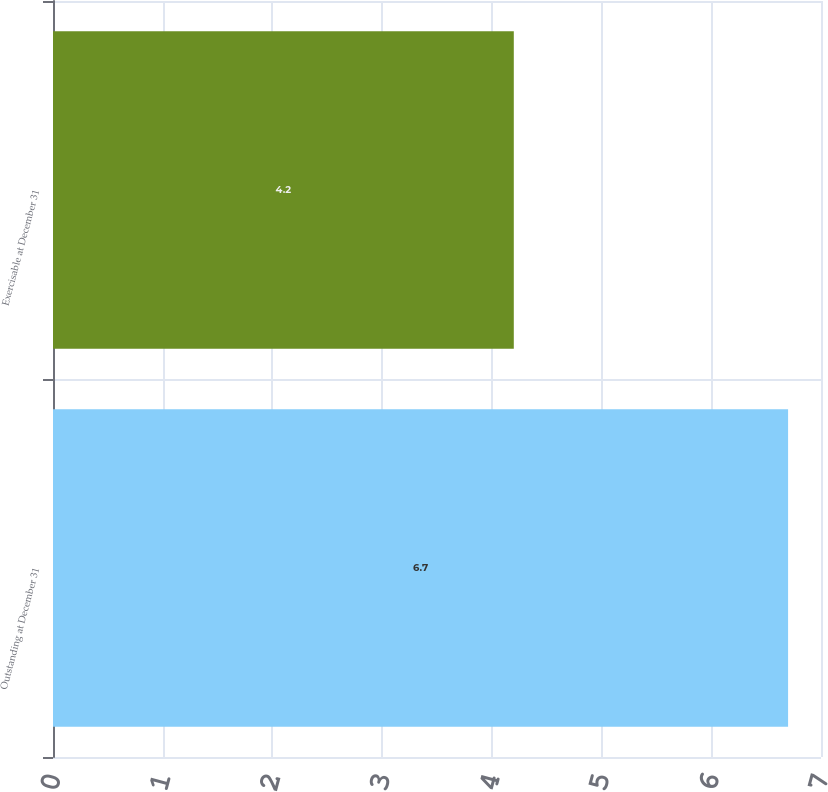Convert chart to OTSL. <chart><loc_0><loc_0><loc_500><loc_500><bar_chart><fcel>Outstanding at December 31<fcel>Exercisable at December 31<nl><fcel>6.7<fcel>4.2<nl></chart> 